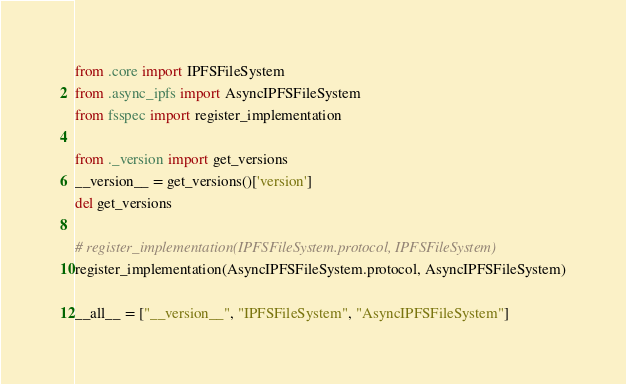Convert code to text. <code><loc_0><loc_0><loc_500><loc_500><_Python_>from .core import IPFSFileSystem
from .async_ipfs import AsyncIPFSFileSystem
from fsspec import register_implementation

from ._version import get_versions
__version__ = get_versions()['version']
del get_versions

# register_implementation(IPFSFileSystem.protocol, IPFSFileSystem)
register_implementation(AsyncIPFSFileSystem.protocol, AsyncIPFSFileSystem)

__all__ = ["__version__", "IPFSFileSystem", "AsyncIPFSFileSystem"]
</code> 